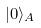Convert formula to latex. <formula><loc_0><loc_0><loc_500><loc_500>| 0 \rangle _ { A }</formula> 